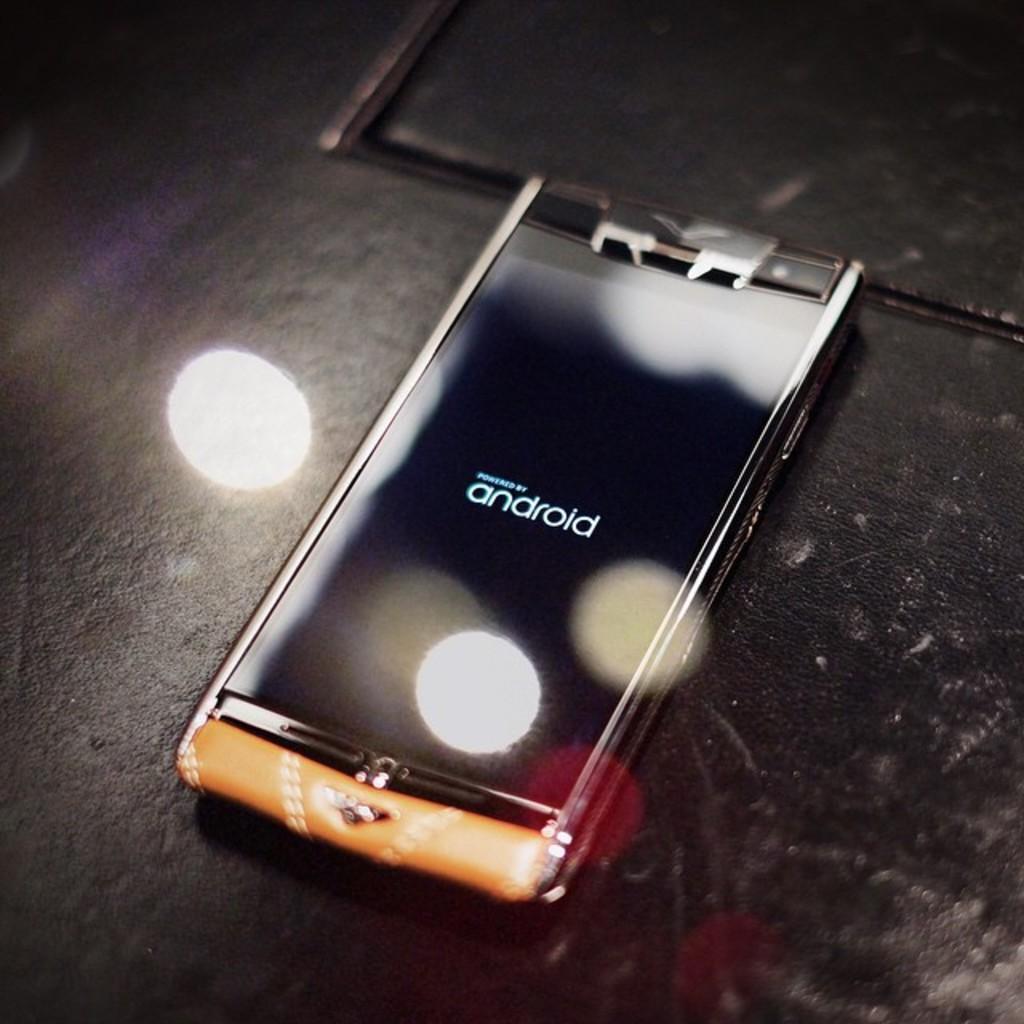What kind of phone is this?
Your response must be concise. Android. 